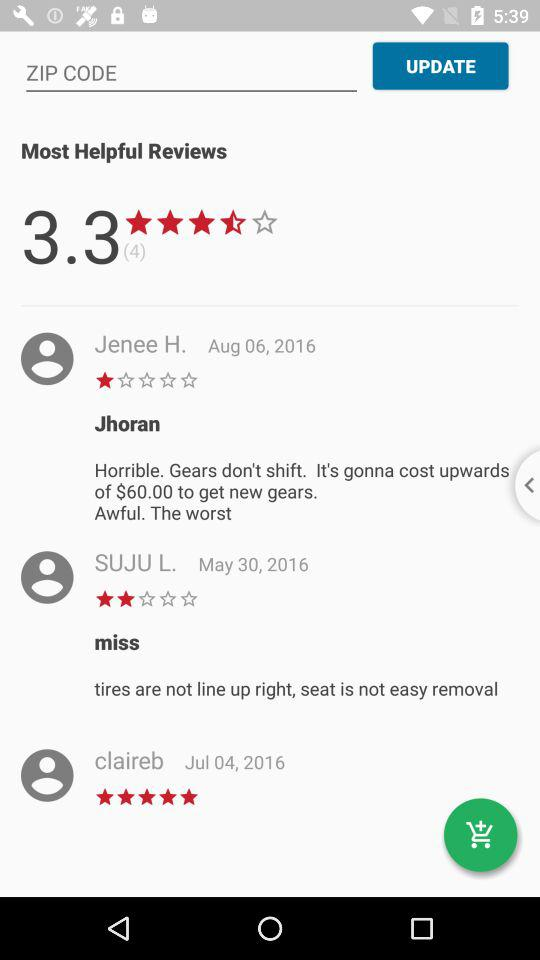What is the average rating? The average rating is 3.3. 